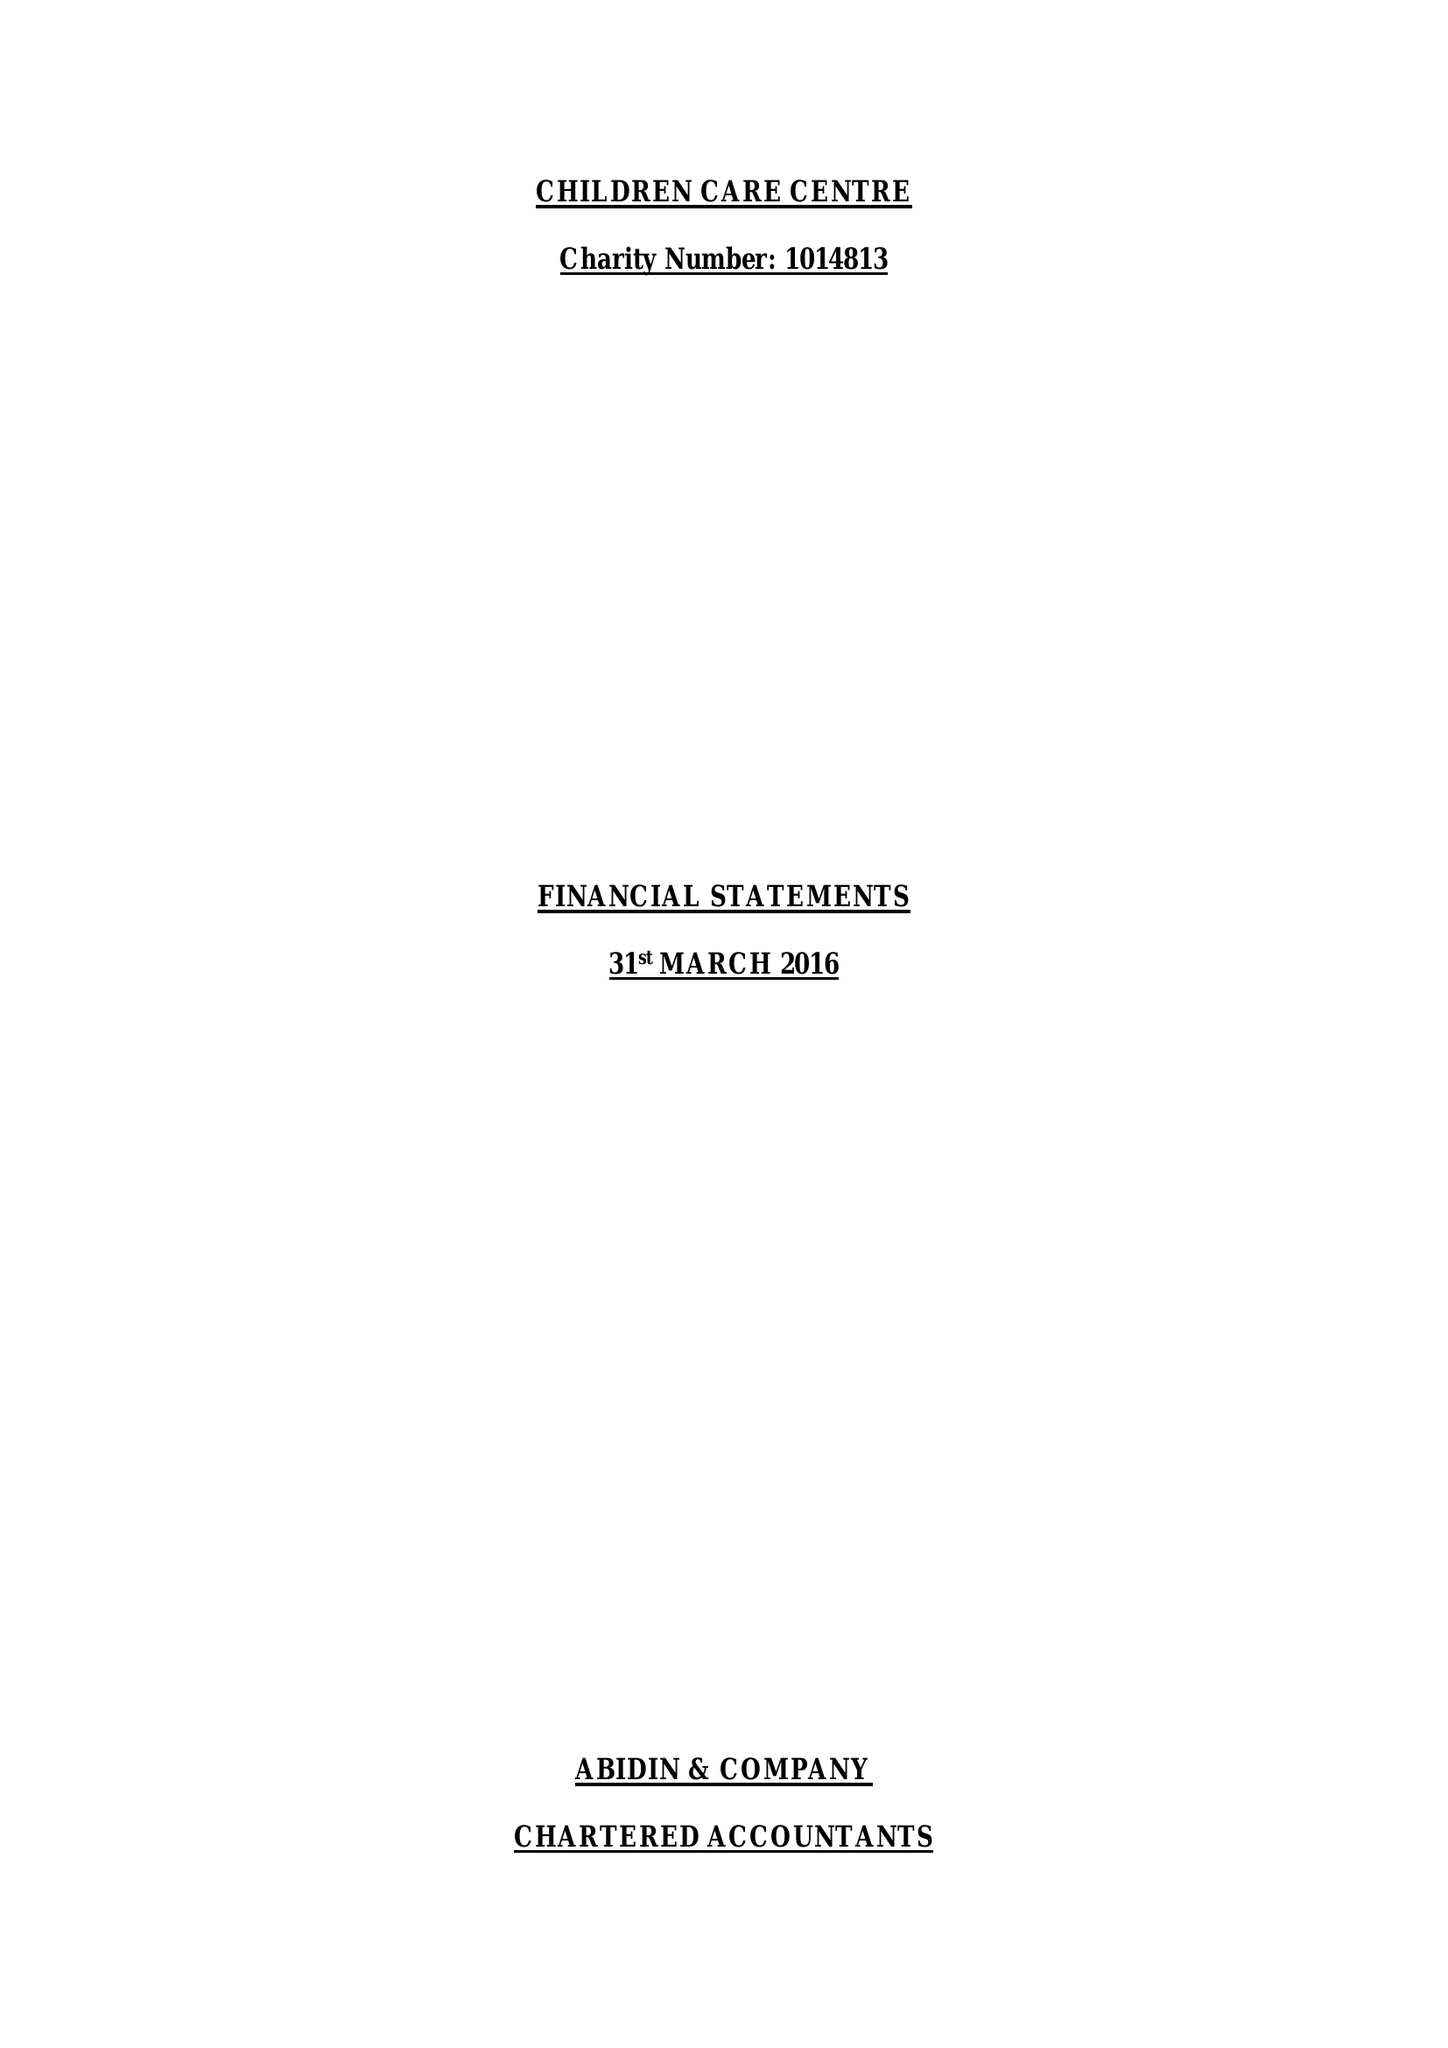What is the value for the charity_number?
Answer the question using a single word or phrase. 1014813 